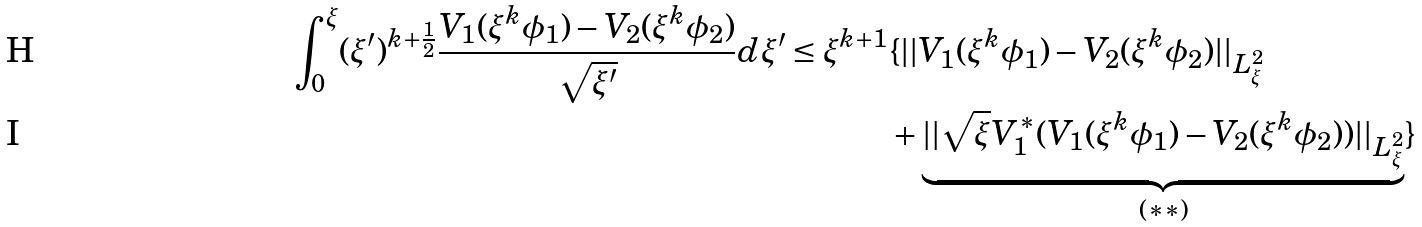Convert formula to latex. <formula><loc_0><loc_0><loc_500><loc_500>\int _ { 0 } ^ { \xi } ( \xi ^ { \prime } ) ^ { k + \frac { 1 } { 2 } } \frac { V _ { 1 } ( \xi ^ { k } \phi _ { 1 } ) - V _ { 2 } ( \xi ^ { k } \phi _ { 2 } ) } { \sqrt { \xi ^ { \prime } } } d \xi ^ { \prime } \leq \xi ^ { k + 1 } & \{ | | V _ { 1 } ( \xi ^ { k } \phi _ { 1 } ) - V _ { 2 } ( \xi ^ { k } \phi _ { 2 } ) | | _ { L ^ { 2 } _ { \xi } } \\ & + \underbrace { | | \sqrt { \xi } V _ { 1 } ^ { \ast } ( V _ { 1 } ( \xi ^ { k } \phi _ { 1 } ) - V _ { 2 } ( \xi ^ { k } \phi _ { 2 } ) ) | | _ { L ^ { 2 } _ { \xi } } } _ { ( \ast \ast ) } \}</formula> 